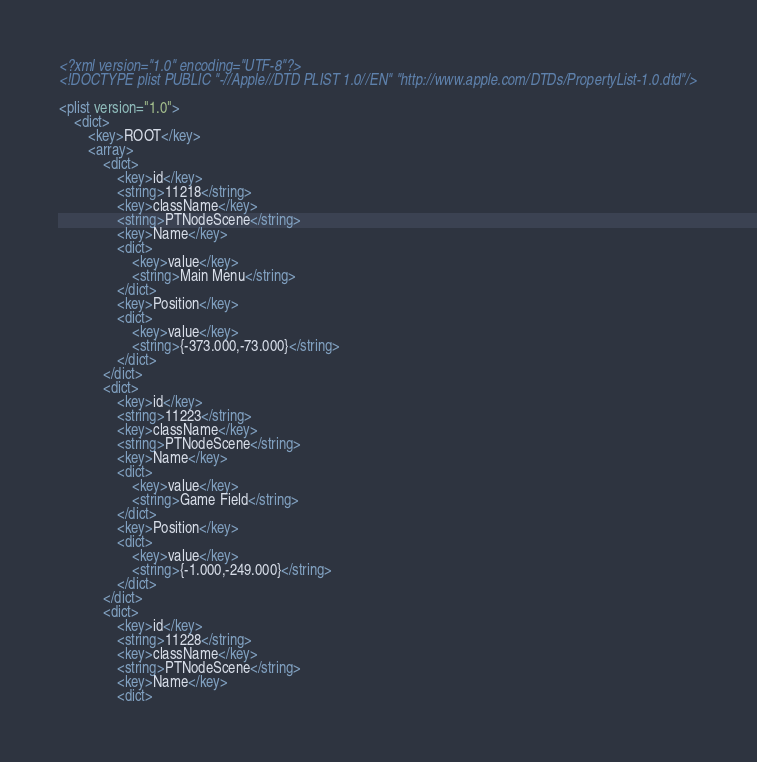<code> <loc_0><loc_0><loc_500><loc_500><_XML_><?xml version="1.0" encoding="UTF-8"?>
<!DOCTYPE plist PUBLIC "-//Apple//DTD PLIST 1.0//EN" "http://www.apple.com/DTDs/PropertyList-1.0.dtd"/>

<plist version="1.0">
    <dict>
        <key>ROOT</key>
        <array>
            <dict>
                <key>id</key>
                <string>11218</string>
                <key>className</key>
                <string>PTNodeScene</string>
                <key>Name</key>
                <dict>
                    <key>value</key>
                    <string>Main Menu</string>
                </dict>
                <key>Position</key>
                <dict>
                    <key>value</key>
                    <string>{-373.000,-73.000}</string>
                </dict>
            </dict>
            <dict>
                <key>id</key>
                <string>11223</string>
                <key>className</key>
                <string>PTNodeScene</string>
                <key>Name</key>
                <dict>
                    <key>value</key>
                    <string>Game Field</string>
                </dict>
                <key>Position</key>
                <dict>
                    <key>value</key>
                    <string>{-1.000,-249.000}</string>
                </dict>
            </dict>
            <dict>
                <key>id</key>
                <string>11228</string>
                <key>className</key>
                <string>PTNodeScene</string>
                <key>Name</key>
                <dict></code> 